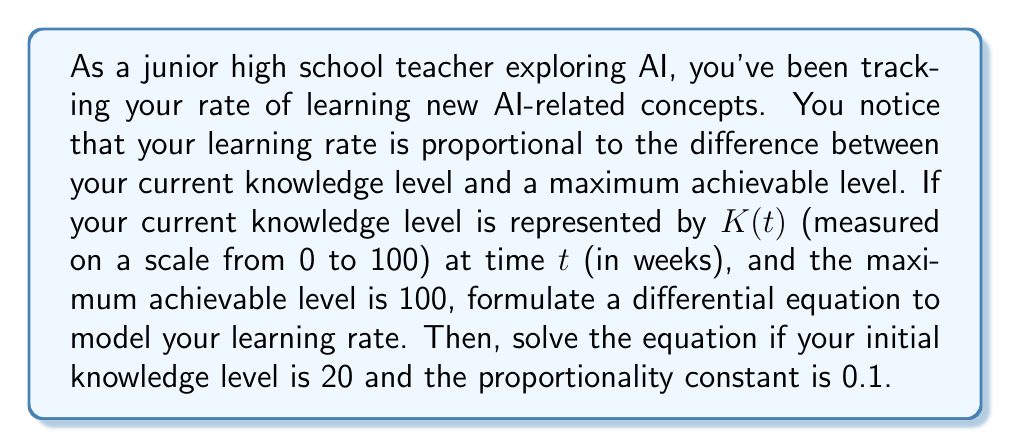Show me your answer to this math problem. Let's approach this step-by-step:

1) First, we need to formulate the differential equation. The rate of change of knowledge ($\frac{dK}{dt}$) is proportional to the difference between the maximum level (100) and the current level $K(t)$. This can be written as:

   $$\frac{dK}{dt} = k(100 - K)$$

   where $k$ is the proportionality constant.

2) We're given that $k = 0.1$, so our equation becomes:

   $$\frac{dK}{dt} = 0.1(100 - K)$$

3) This is a separable first-order differential equation. To solve it, we separate the variables:

   $$\frac{dK}{100 - K} = 0.1dt$$

4) Integrate both sides:

   $$\int \frac{dK}{100 - K} = \int 0.1dt$$

5) The left side integrates to $-\ln|100 - K|$, and the right side to $0.1t + C$:

   $$-\ln|100 - K| = 0.1t + C$$

6) Solve for $K$:

   $$\ln|100 - K| = -0.1t - C$$
   $$100 - K = e^{-0.1t - C} = Ae^{-0.1t}$$, where $A = e^{-C}$
   $$K = 100 - Ae^{-0.1t}$$

7) Use the initial condition $K(0) = 20$ to find $A$:

   $$20 = 100 - A$$
   $$A = 80$$

8) Therefore, the solution is:

   $$K(t) = 100 - 80e^{-0.1t}$$

This equation models your knowledge level $K$ at any time $t$ (in weeks).
Answer: $$K(t) = 100 - 80e^{-0.1t}$$ 